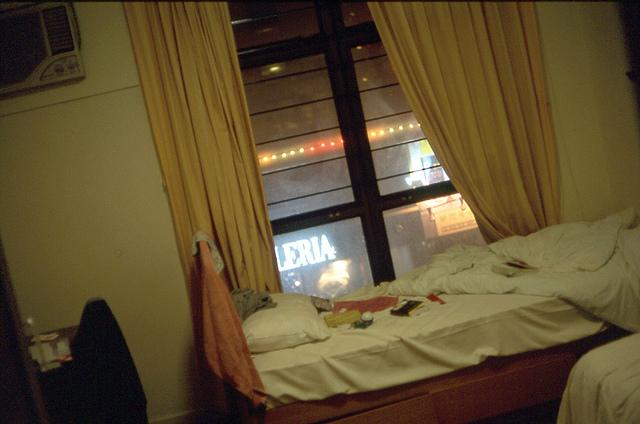The last four letters seen in the background are all found in what word? galleria 